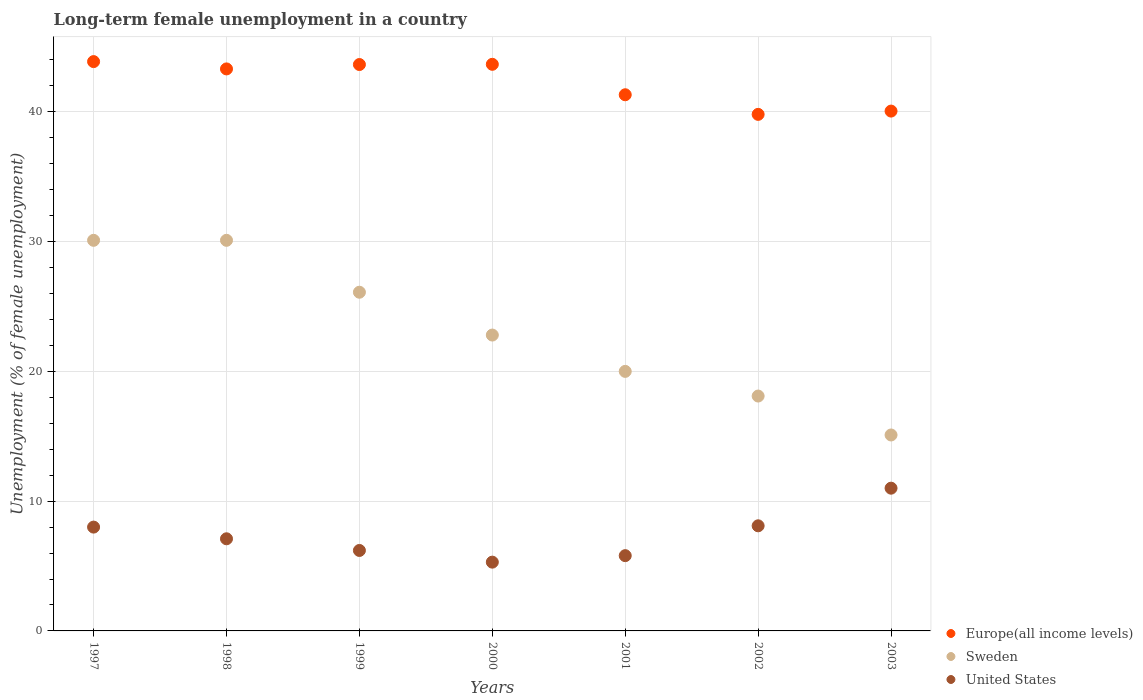What is the percentage of long-term unemployed female population in Europe(all income levels) in 2001?
Give a very brief answer. 41.32. Across all years, what is the minimum percentage of long-term unemployed female population in United States?
Make the answer very short. 5.3. In which year was the percentage of long-term unemployed female population in United States minimum?
Ensure brevity in your answer.  2000. What is the total percentage of long-term unemployed female population in Sweden in the graph?
Give a very brief answer. 162.3. What is the difference between the percentage of long-term unemployed female population in Sweden in 2000 and that in 2002?
Give a very brief answer. 4.7. What is the difference between the percentage of long-term unemployed female population in Sweden in 1997 and the percentage of long-term unemployed female population in United States in 2000?
Your response must be concise. 24.8. What is the average percentage of long-term unemployed female population in Sweden per year?
Give a very brief answer. 23.19. In the year 2000, what is the difference between the percentage of long-term unemployed female population in Europe(all income levels) and percentage of long-term unemployed female population in United States?
Give a very brief answer. 38.36. What is the ratio of the percentage of long-term unemployed female population in Sweden in 1998 to that in 2003?
Provide a short and direct response. 1.99. Is the percentage of long-term unemployed female population in Europe(all income levels) in 1997 less than that in 1998?
Provide a succinct answer. No. Is the difference between the percentage of long-term unemployed female population in Europe(all income levels) in 1999 and 2000 greater than the difference between the percentage of long-term unemployed female population in United States in 1999 and 2000?
Provide a short and direct response. No. What is the difference between the highest and the second highest percentage of long-term unemployed female population in United States?
Offer a terse response. 2.9. What is the difference between the highest and the lowest percentage of long-term unemployed female population in United States?
Ensure brevity in your answer.  5.7. In how many years, is the percentage of long-term unemployed female population in Sweden greater than the average percentage of long-term unemployed female population in Sweden taken over all years?
Your response must be concise. 3. Is the sum of the percentage of long-term unemployed female population in United States in 1999 and 2000 greater than the maximum percentage of long-term unemployed female population in Sweden across all years?
Your answer should be very brief. No. Does the percentage of long-term unemployed female population in Europe(all income levels) monotonically increase over the years?
Give a very brief answer. No. Is the percentage of long-term unemployed female population in Sweden strictly greater than the percentage of long-term unemployed female population in Europe(all income levels) over the years?
Provide a short and direct response. No. Is the percentage of long-term unemployed female population in Sweden strictly less than the percentage of long-term unemployed female population in Europe(all income levels) over the years?
Keep it short and to the point. Yes. How many dotlines are there?
Give a very brief answer. 3. How many years are there in the graph?
Keep it short and to the point. 7. What is the difference between two consecutive major ticks on the Y-axis?
Your answer should be very brief. 10. Are the values on the major ticks of Y-axis written in scientific E-notation?
Your answer should be very brief. No. Where does the legend appear in the graph?
Offer a terse response. Bottom right. How are the legend labels stacked?
Offer a very short reply. Vertical. What is the title of the graph?
Ensure brevity in your answer.  Long-term female unemployment in a country. Does "Lao PDR" appear as one of the legend labels in the graph?
Provide a succinct answer. No. What is the label or title of the X-axis?
Your answer should be very brief. Years. What is the label or title of the Y-axis?
Provide a succinct answer. Unemployment (% of female unemployment). What is the Unemployment (% of female unemployment) in Europe(all income levels) in 1997?
Your response must be concise. 43.87. What is the Unemployment (% of female unemployment) of Sweden in 1997?
Give a very brief answer. 30.1. What is the Unemployment (% of female unemployment) in United States in 1997?
Keep it short and to the point. 8. What is the Unemployment (% of female unemployment) in Europe(all income levels) in 1998?
Offer a terse response. 43.31. What is the Unemployment (% of female unemployment) of Sweden in 1998?
Ensure brevity in your answer.  30.1. What is the Unemployment (% of female unemployment) in United States in 1998?
Make the answer very short. 7.1. What is the Unemployment (% of female unemployment) of Europe(all income levels) in 1999?
Offer a terse response. 43.65. What is the Unemployment (% of female unemployment) of Sweden in 1999?
Provide a succinct answer. 26.1. What is the Unemployment (% of female unemployment) in United States in 1999?
Provide a short and direct response. 6.2. What is the Unemployment (% of female unemployment) of Europe(all income levels) in 2000?
Provide a short and direct response. 43.66. What is the Unemployment (% of female unemployment) in Sweden in 2000?
Your answer should be compact. 22.8. What is the Unemployment (% of female unemployment) in United States in 2000?
Ensure brevity in your answer.  5.3. What is the Unemployment (% of female unemployment) in Europe(all income levels) in 2001?
Ensure brevity in your answer.  41.32. What is the Unemployment (% of female unemployment) in United States in 2001?
Your response must be concise. 5.8. What is the Unemployment (% of female unemployment) in Europe(all income levels) in 2002?
Offer a terse response. 39.81. What is the Unemployment (% of female unemployment) in Sweden in 2002?
Provide a succinct answer. 18.1. What is the Unemployment (% of female unemployment) in United States in 2002?
Your response must be concise. 8.1. What is the Unemployment (% of female unemployment) in Europe(all income levels) in 2003?
Make the answer very short. 40.06. What is the Unemployment (% of female unemployment) in Sweden in 2003?
Your answer should be very brief. 15.1. What is the Unemployment (% of female unemployment) of United States in 2003?
Provide a short and direct response. 11. Across all years, what is the maximum Unemployment (% of female unemployment) in Europe(all income levels)?
Your response must be concise. 43.87. Across all years, what is the maximum Unemployment (% of female unemployment) of Sweden?
Make the answer very short. 30.1. Across all years, what is the minimum Unemployment (% of female unemployment) of Europe(all income levels)?
Keep it short and to the point. 39.81. Across all years, what is the minimum Unemployment (% of female unemployment) in Sweden?
Your response must be concise. 15.1. Across all years, what is the minimum Unemployment (% of female unemployment) of United States?
Offer a terse response. 5.3. What is the total Unemployment (% of female unemployment) in Europe(all income levels) in the graph?
Ensure brevity in your answer.  295.67. What is the total Unemployment (% of female unemployment) of Sweden in the graph?
Your response must be concise. 162.3. What is the total Unemployment (% of female unemployment) in United States in the graph?
Your answer should be compact. 51.5. What is the difference between the Unemployment (% of female unemployment) in Europe(all income levels) in 1997 and that in 1998?
Offer a terse response. 0.56. What is the difference between the Unemployment (% of female unemployment) in Sweden in 1997 and that in 1998?
Your answer should be compact. 0. What is the difference between the Unemployment (% of female unemployment) of United States in 1997 and that in 1998?
Offer a terse response. 0.9. What is the difference between the Unemployment (% of female unemployment) of Europe(all income levels) in 1997 and that in 1999?
Make the answer very short. 0.23. What is the difference between the Unemployment (% of female unemployment) of Sweden in 1997 and that in 1999?
Offer a terse response. 4. What is the difference between the Unemployment (% of female unemployment) in United States in 1997 and that in 1999?
Offer a terse response. 1.8. What is the difference between the Unemployment (% of female unemployment) in Europe(all income levels) in 1997 and that in 2000?
Provide a succinct answer. 0.21. What is the difference between the Unemployment (% of female unemployment) in Sweden in 1997 and that in 2000?
Offer a very short reply. 7.3. What is the difference between the Unemployment (% of female unemployment) of United States in 1997 and that in 2000?
Make the answer very short. 2.7. What is the difference between the Unemployment (% of female unemployment) in Europe(all income levels) in 1997 and that in 2001?
Your answer should be compact. 2.55. What is the difference between the Unemployment (% of female unemployment) in Sweden in 1997 and that in 2001?
Your response must be concise. 10.1. What is the difference between the Unemployment (% of female unemployment) of United States in 1997 and that in 2001?
Keep it short and to the point. 2.2. What is the difference between the Unemployment (% of female unemployment) of Europe(all income levels) in 1997 and that in 2002?
Your answer should be very brief. 4.07. What is the difference between the Unemployment (% of female unemployment) in Sweden in 1997 and that in 2002?
Your answer should be compact. 12. What is the difference between the Unemployment (% of female unemployment) of United States in 1997 and that in 2002?
Your response must be concise. -0.1. What is the difference between the Unemployment (% of female unemployment) of Europe(all income levels) in 1997 and that in 2003?
Offer a very short reply. 3.81. What is the difference between the Unemployment (% of female unemployment) in Sweden in 1997 and that in 2003?
Your answer should be compact. 15. What is the difference between the Unemployment (% of female unemployment) in Europe(all income levels) in 1998 and that in 1999?
Offer a very short reply. -0.34. What is the difference between the Unemployment (% of female unemployment) in Europe(all income levels) in 1998 and that in 2000?
Give a very brief answer. -0.35. What is the difference between the Unemployment (% of female unemployment) of Europe(all income levels) in 1998 and that in 2001?
Make the answer very short. 1.99. What is the difference between the Unemployment (% of female unemployment) of Sweden in 1998 and that in 2001?
Offer a terse response. 10.1. What is the difference between the Unemployment (% of female unemployment) in Europe(all income levels) in 1998 and that in 2002?
Your answer should be very brief. 3.5. What is the difference between the Unemployment (% of female unemployment) in Sweden in 1998 and that in 2002?
Make the answer very short. 12. What is the difference between the Unemployment (% of female unemployment) in United States in 1998 and that in 2002?
Your answer should be very brief. -1. What is the difference between the Unemployment (% of female unemployment) of Europe(all income levels) in 1998 and that in 2003?
Give a very brief answer. 3.25. What is the difference between the Unemployment (% of female unemployment) in Sweden in 1998 and that in 2003?
Offer a terse response. 15. What is the difference between the Unemployment (% of female unemployment) in United States in 1998 and that in 2003?
Your answer should be compact. -3.9. What is the difference between the Unemployment (% of female unemployment) of Europe(all income levels) in 1999 and that in 2000?
Your answer should be very brief. -0.02. What is the difference between the Unemployment (% of female unemployment) of Sweden in 1999 and that in 2000?
Provide a short and direct response. 3.3. What is the difference between the Unemployment (% of female unemployment) of Europe(all income levels) in 1999 and that in 2001?
Your answer should be compact. 2.33. What is the difference between the Unemployment (% of female unemployment) in Sweden in 1999 and that in 2001?
Provide a short and direct response. 6.1. What is the difference between the Unemployment (% of female unemployment) of United States in 1999 and that in 2001?
Make the answer very short. 0.4. What is the difference between the Unemployment (% of female unemployment) of Europe(all income levels) in 1999 and that in 2002?
Your answer should be compact. 3.84. What is the difference between the Unemployment (% of female unemployment) of United States in 1999 and that in 2002?
Your answer should be very brief. -1.9. What is the difference between the Unemployment (% of female unemployment) of Europe(all income levels) in 1999 and that in 2003?
Your response must be concise. 3.59. What is the difference between the Unemployment (% of female unemployment) in Europe(all income levels) in 2000 and that in 2001?
Make the answer very short. 2.35. What is the difference between the Unemployment (% of female unemployment) in Sweden in 2000 and that in 2001?
Your answer should be compact. 2.8. What is the difference between the Unemployment (% of female unemployment) of Europe(all income levels) in 2000 and that in 2002?
Your answer should be compact. 3.86. What is the difference between the Unemployment (% of female unemployment) of Europe(all income levels) in 2000 and that in 2003?
Offer a terse response. 3.6. What is the difference between the Unemployment (% of female unemployment) in United States in 2000 and that in 2003?
Keep it short and to the point. -5.7. What is the difference between the Unemployment (% of female unemployment) in Europe(all income levels) in 2001 and that in 2002?
Keep it short and to the point. 1.51. What is the difference between the Unemployment (% of female unemployment) of Sweden in 2001 and that in 2002?
Keep it short and to the point. 1.9. What is the difference between the Unemployment (% of female unemployment) in Europe(all income levels) in 2001 and that in 2003?
Provide a short and direct response. 1.26. What is the difference between the Unemployment (% of female unemployment) of Sweden in 2001 and that in 2003?
Provide a short and direct response. 4.9. What is the difference between the Unemployment (% of female unemployment) in Europe(all income levels) in 2002 and that in 2003?
Keep it short and to the point. -0.25. What is the difference between the Unemployment (% of female unemployment) in Sweden in 2002 and that in 2003?
Offer a very short reply. 3. What is the difference between the Unemployment (% of female unemployment) of United States in 2002 and that in 2003?
Offer a very short reply. -2.9. What is the difference between the Unemployment (% of female unemployment) of Europe(all income levels) in 1997 and the Unemployment (% of female unemployment) of Sweden in 1998?
Offer a very short reply. 13.77. What is the difference between the Unemployment (% of female unemployment) of Europe(all income levels) in 1997 and the Unemployment (% of female unemployment) of United States in 1998?
Offer a terse response. 36.77. What is the difference between the Unemployment (% of female unemployment) of Sweden in 1997 and the Unemployment (% of female unemployment) of United States in 1998?
Offer a very short reply. 23. What is the difference between the Unemployment (% of female unemployment) in Europe(all income levels) in 1997 and the Unemployment (% of female unemployment) in Sweden in 1999?
Make the answer very short. 17.77. What is the difference between the Unemployment (% of female unemployment) of Europe(all income levels) in 1997 and the Unemployment (% of female unemployment) of United States in 1999?
Provide a short and direct response. 37.67. What is the difference between the Unemployment (% of female unemployment) of Sweden in 1997 and the Unemployment (% of female unemployment) of United States in 1999?
Give a very brief answer. 23.9. What is the difference between the Unemployment (% of female unemployment) in Europe(all income levels) in 1997 and the Unemployment (% of female unemployment) in Sweden in 2000?
Provide a short and direct response. 21.07. What is the difference between the Unemployment (% of female unemployment) in Europe(all income levels) in 1997 and the Unemployment (% of female unemployment) in United States in 2000?
Provide a short and direct response. 38.57. What is the difference between the Unemployment (% of female unemployment) of Sweden in 1997 and the Unemployment (% of female unemployment) of United States in 2000?
Your answer should be very brief. 24.8. What is the difference between the Unemployment (% of female unemployment) in Europe(all income levels) in 1997 and the Unemployment (% of female unemployment) in Sweden in 2001?
Your answer should be compact. 23.87. What is the difference between the Unemployment (% of female unemployment) of Europe(all income levels) in 1997 and the Unemployment (% of female unemployment) of United States in 2001?
Provide a short and direct response. 38.07. What is the difference between the Unemployment (% of female unemployment) of Sweden in 1997 and the Unemployment (% of female unemployment) of United States in 2001?
Ensure brevity in your answer.  24.3. What is the difference between the Unemployment (% of female unemployment) of Europe(all income levels) in 1997 and the Unemployment (% of female unemployment) of Sweden in 2002?
Provide a succinct answer. 25.77. What is the difference between the Unemployment (% of female unemployment) in Europe(all income levels) in 1997 and the Unemployment (% of female unemployment) in United States in 2002?
Your answer should be compact. 35.77. What is the difference between the Unemployment (% of female unemployment) in Europe(all income levels) in 1997 and the Unemployment (% of female unemployment) in Sweden in 2003?
Offer a terse response. 28.77. What is the difference between the Unemployment (% of female unemployment) in Europe(all income levels) in 1997 and the Unemployment (% of female unemployment) in United States in 2003?
Give a very brief answer. 32.87. What is the difference between the Unemployment (% of female unemployment) of Sweden in 1997 and the Unemployment (% of female unemployment) of United States in 2003?
Your response must be concise. 19.1. What is the difference between the Unemployment (% of female unemployment) in Europe(all income levels) in 1998 and the Unemployment (% of female unemployment) in Sweden in 1999?
Offer a terse response. 17.21. What is the difference between the Unemployment (% of female unemployment) of Europe(all income levels) in 1998 and the Unemployment (% of female unemployment) of United States in 1999?
Your response must be concise. 37.11. What is the difference between the Unemployment (% of female unemployment) of Sweden in 1998 and the Unemployment (% of female unemployment) of United States in 1999?
Give a very brief answer. 23.9. What is the difference between the Unemployment (% of female unemployment) in Europe(all income levels) in 1998 and the Unemployment (% of female unemployment) in Sweden in 2000?
Make the answer very short. 20.51. What is the difference between the Unemployment (% of female unemployment) of Europe(all income levels) in 1998 and the Unemployment (% of female unemployment) of United States in 2000?
Ensure brevity in your answer.  38.01. What is the difference between the Unemployment (% of female unemployment) of Sweden in 1998 and the Unemployment (% of female unemployment) of United States in 2000?
Ensure brevity in your answer.  24.8. What is the difference between the Unemployment (% of female unemployment) in Europe(all income levels) in 1998 and the Unemployment (% of female unemployment) in Sweden in 2001?
Offer a terse response. 23.31. What is the difference between the Unemployment (% of female unemployment) of Europe(all income levels) in 1998 and the Unemployment (% of female unemployment) of United States in 2001?
Your answer should be very brief. 37.51. What is the difference between the Unemployment (% of female unemployment) of Sweden in 1998 and the Unemployment (% of female unemployment) of United States in 2001?
Your answer should be compact. 24.3. What is the difference between the Unemployment (% of female unemployment) in Europe(all income levels) in 1998 and the Unemployment (% of female unemployment) in Sweden in 2002?
Offer a very short reply. 25.21. What is the difference between the Unemployment (% of female unemployment) in Europe(all income levels) in 1998 and the Unemployment (% of female unemployment) in United States in 2002?
Keep it short and to the point. 35.21. What is the difference between the Unemployment (% of female unemployment) of Europe(all income levels) in 1998 and the Unemployment (% of female unemployment) of Sweden in 2003?
Provide a succinct answer. 28.21. What is the difference between the Unemployment (% of female unemployment) in Europe(all income levels) in 1998 and the Unemployment (% of female unemployment) in United States in 2003?
Your answer should be compact. 32.31. What is the difference between the Unemployment (% of female unemployment) of Europe(all income levels) in 1999 and the Unemployment (% of female unemployment) of Sweden in 2000?
Make the answer very short. 20.85. What is the difference between the Unemployment (% of female unemployment) in Europe(all income levels) in 1999 and the Unemployment (% of female unemployment) in United States in 2000?
Ensure brevity in your answer.  38.35. What is the difference between the Unemployment (% of female unemployment) in Sweden in 1999 and the Unemployment (% of female unemployment) in United States in 2000?
Offer a terse response. 20.8. What is the difference between the Unemployment (% of female unemployment) in Europe(all income levels) in 1999 and the Unemployment (% of female unemployment) in Sweden in 2001?
Provide a short and direct response. 23.65. What is the difference between the Unemployment (% of female unemployment) of Europe(all income levels) in 1999 and the Unemployment (% of female unemployment) of United States in 2001?
Give a very brief answer. 37.85. What is the difference between the Unemployment (% of female unemployment) in Sweden in 1999 and the Unemployment (% of female unemployment) in United States in 2001?
Your answer should be very brief. 20.3. What is the difference between the Unemployment (% of female unemployment) of Europe(all income levels) in 1999 and the Unemployment (% of female unemployment) of Sweden in 2002?
Give a very brief answer. 25.55. What is the difference between the Unemployment (% of female unemployment) of Europe(all income levels) in 1999 and the Unemployment (% of female unemployment) of United States in 2002?
Make the answer very short. 35.55. What is the difference between the Unemployment (% of female unemployment) in Sweden in 1999 and the Unemployment (% of female unemployment) in United States in 2002?
Give a very brief answer. 18. What is the difference between the Unemployment (% of female unemployment) in Europe(all income levels) in 1999 and the Unemployment (% of female unemployment) in Sweden in 2003?
Your answer should be very brief. 28.55. What is the difference between the Unemployment (% of female unemployment) of Europe(all income levels) in 1999 and the Unemployment (% of female unemployment) of United States in 2003?
Offer a terse response. 32.65. What is the difference between the Unemployment (% of female unemployment) in Europe(all income levels) in 2000 and the Unemployment (% of female unemployment) in Sweden in 2001?
Keep it short and to the point. 23.66. What is the difference between the Unemployment (% of female unemployment) in Europe(all income levels) in 2000 and the Unemployment (% of female unemployment) in United States in 2001?
Keep it short and to the point. 37.86. What is the difference between the Unemployment (% of female unemployment) of Sweden in 2000 and the Unemployment (% of female unemployment) of United States in 2001?
Make the answer very short. 17. What is the difference between the Unemployment (% of female unemployment) of Europe(all income levels) in 2000 and the Unemployment (% of female unemployment) of Sweden in 2002?
Your answer should be very brief. 25.56. What is the difference between the Unemployment (% of female unemployment) in Europe(all income levels) in 2000 and the Unemployment (% of female unemployment) in United States in 2002?
Give a very brief answer. 35.56. What is the difference between the Unemployment (% of female unemployment) in Europe(all income levels) in 2000 and the Unemployment (% of female unemployment) in Sweden in 2003?
Ensure brevity in your answer.  28.56. What is the difference between the Unemployment (% of female unemployment) in Europe(all income levels) in 2000 and the Unemployment (% of female unemployment) in United States in 2003?
Your answer should be very brief. 32.66. What is the difference between the Unemployment (% of female unemployment) of Europe(all income levels) in 2001 and the Unemployment (% of female unemployment) of Sweden in 2002?
Give a very brief answer. 23.22. What is the difference between the Unemployment (% of female unemployment) in Europe(all income levels) in 2001 and the Unemployment (% of female unemployment) in United States in 2002?
Provide a short and direct response. 33.22. What is the difference between the Unemployment (% of female unemployment) of Sweden in 2001 and the Unemployment (% of female unemployment) of United States in 2002?
Provide a short and direct response. 11.9. What is the difference between the Unemployment (% of female unemployment) of Europe(all income levels) in 2001 and the Unemployment (% of female unemployment) of Sweden in 2003?
Provide a short and direct response. 26.22. What is the difference between the Unemployment (% of female unemployment) of Europe(all income levels) in 2001 and the Unemployment (% of female unemployment) of United States in 2003?
Provide a short and direct response. 30.32. What is the difference between the Unemployment (% of female unemployment) of Europe(all income levels) in 2002 and the Unemployment (% of female unemployment) of Sweden in 2003?
Keep it short and to the point. 24.71. What is the difference between the Unemployment (% of female unemployment) of Europe(all income levels) in 2002 and the Unemployment (% of female unemployment) of United States in 2003?
Provide a short and direct response. 28.81. What is the difference between the Unemployment (% of female unemployment) in Sweden in 2002 and the Unemployment (% of female unemployment) in United States in 2003?
Provide a short and direct response. 7.1. What is the average Unemployment (% of female unemployment) of Europe(all income levels) per year?
Make the answer very short. 42.24. What is the average Unemployment (% of female unemployment) in Sweden per year?
Your response must be concise. 23.19. What is the average Unemployment (% of female unemployment) of United States per year?
Your response must be concise. 7.36. In the year 1997, what is the difference between the Unemployment (% of female unemployment) of Europe(all income levels) and Unemployment (% of female unemployment) of Sweden?
Your response must be concise. 13.77. In the year 1997, what is the difference between the Unemployment (% of female unemployment) in Europe(all income levels) and Unemployment (% of female unemployment) in United States?
Offer a terse response. 35.87. In the year 1997, what is the difference between the Unemployment (% of female unemployment) in Sweden and Unemployment (% of female unemployment) in United States?
Your response must be concise. 22.1. In the year 1998, what is the difference between the Unemployment (% of female unemployment) of Europe(all income levels) and Unemployment (% of female unemployment) of Sweden?
Make the answer very short. 13.21. In the year 1998, what is the difference between the Unemployment (% of female unemployment) of Europe(all income levels) and Unemployment (% of female unemployment) of United States?
Offer a terse response. 36.21. In the year 1998, what is the difference between the Unemployment (% of female unemployment) in Sweden and Unemployment (% of female unemployment) in United States?
Your answer should be compact. 23. In the year 1999, what is the difference between the Unemployment (% of female unemployment) of Europe(all income levels) and Unemployment (% of female unemployment) of Sweden?
Make the answer very short. 17.55. In the year 1999, what is the difference between the Unemployment (% of female unemployment) in Europe(all income levels) and Unemployment (% of female unemployment) in United States?
Your answer should be very brief. 37.45. In the year 1999, what is the difference between the Unemployment (% of female unemployment) of Sweden and Unemployment (% of female unemployment) of United States?
Your answer should be very brief. 19.9. In the year 2000, what is the difference between the Unemployment (% of female unemployment) in Europe(all income levels) and Unemployment (% of female unemployment) in Sweden?
Keep it short and to the point. 20.86. In the year 2000, what is the difference between the Unemployment (% of female unemployment) in Europe(all income levels) and Unemployment (% of female unemployment) in United States?
Ensure brevity in your answer.  38.36. In the year 2001, what is the difference between the Unemployment (% of female unemployment) in Europe(all income levels) and Unemployment (% of female unemployment) in Sweden?
Provide a succinct answer. 21.32. In the year 2001, what is the difference between the Unemployment (% of female unemployment) in Europe(all income levels) and Unemployment (% of female unemployment) in United States?
Your response must be concise. 35.52. In the year 2001, what is the difference between the Unemployment (% of female unemployment) in Sweden and Unemployment (% of female unemployment) in United States?
Offer a very short reply. 14.2. In the year 2002, what is the difference between the Unemployment (% of female unemployment) of Europe(all income levels) and Unemployment (% of female unemployment) of Sweden?
Provide a succinct answer. 21.71. In the year 2002, what is the difference between the Unemployment (% of female unemployment) in Europe(all income levels) and Unemployment (% of female unemployment) in United States?
Your answer should be compact. 31.71. In the year 2003, what is the difference between the Unemployment (% of female unemployment) in Europe(all income levels) and Unemployment (% of female unemployment) in Sweden?
Provide a succinct answer. 24.96. In the year 2003, what is the difference between the Unemployment (% of female unemployment) in Europe(all income levels) and Unemployment (% of female unemployment) in United States?
Provide a short and direct response. 29.06. What is the ratio of the Unemployment (% of female unemployment) of United States in 1997 to that in 1998?
Provide a succinct answer. 1.13. What is the ratio of the Unemployment (% of female unemployment) in Europe(all income levels) in 1997 to that in 1999?
Your response must be concise. 1.01. What is the ratio of the Unemployment (% of female unemployment) of Sweden in 1997 to that in 1999?
Make the answer very short. 1.15. What is the ratio of the Unemployment (% of female unemployment) of United States in 1997 to that in 1999?
Keep it short and to the point. 1.29. What is the ratio of the Unemployment (% of female unemployment) of Sweden in 1997 to that in 2000?
Make the answer very short. 1.32. What is the ratio of the Unemployment (% of female unemployment) in United States in 1997 to that in 2000?
Offer a terse response. 1.51. What is the ratio of the Unemployment (% of female unemployment) in Europe(all income levels) in 1997 to that in 2001?
Ensure brevity in your answer.  1.06. What is the ratio of the Unemployment (% of female unemployment) in Sweden in 1997 to that in 2001?
Keep it short and to the point. 1.5. What is the ratio of the Unemployment (% of female unemployment) in United States in 1997 to that in 2001?
Give a very brief answer. 1.38. What is the ratio of the Unemployment (% of female unemployment) in Europe(all income levels) in 1997 to that in 2002?
Offer a very short reply. 1.1. What is the ratio of the Unemployment (% of female unemployment) in Sweden in 1997 to that in 2002?
Provide a short and direct response. 1.66. What is the ratio of the Unemployment (% of female unemployment) in United States in 1997 to that in 2002?
Offer a terse response. 0.99. What is the ratio of the Unemployment (% of female unemployment) of Europe(all income levels) in 1997 to that in 2003?
Give a very brief answer. 1.1. What is the ratio of the Unemployment (% of female unemployment) of Sweden in 1997 to that in 2003?
Provide a short and direct response. 1.99. What is the ratio of the Unemployment (% of female unemployment) of United States in 1997 to that in 2003?
Your answer should be compact. 0.73. What is the ratio of the Unemployment (% of female unemployment) of Europe(all income levels) in 1998 to that in 1999?
Provide a succinct answer. 0.99. What is the ratio of the Unemployment (% of female unemployment) of Sweden in 1998 to that in 1999?
Your response must be concise. 1.15. What is the ratio of the Unemployment (% of female unemployment) in United States in 1998 to that in 1999?
Offer a terse response. 1.15. What is the ratio of the Unemployment (% of female unemployment) of Europe(all income levels) in 1998 to that in 2000?
Ensure brevity in your answer.  0.99. What is the ratio of the Unemployment (% of female unemployment) of Sweden in 1998 to that in 2000?
Your answer should be very brief. 1.32. What is the ratio of the Unemployment (% of female unemployment) of United States in 1998 to that in 2000?
Offer a terse response. 1.34. What is the ratio of the Unemployment (% of female unemployment) of Europe(all income levels) in 1998 to that in 2001?
Your answer should be very brief. 1.05. What is the ratio of the Unemployment (% of female unemployment) in Sweden in 1998 to that in 2001?
Provide a short and direct response. 1.5. What is the ratio of the Unemployment (% of female unemployment) of United States in 1998 to that in 2001?
Provide a succinct answer. 1.22. What is the ratio of the Unemployment (% of female unemployment) of Europe(all income levels) in 1998 to that in 2002?
Your answer should be compact. 1.09. What is the ratio of the Unemployment (% of female unemployment) of Sweden in 1998 to that in 2002?
Your answer should be very brief. 1.66. What is the ratio of the Unemployment (% of female unemployment) of United States in 1998 to that in 2002?
Your answer should be compact. 0.88. What is the ratio of the Unemployment (% of female unemployment) of Europe(all income levels) in 1998 to that in 2003?
Your answer should be compact. 1.08. What is the ratio of the Unemployment (% of female unemployment) in Sweden in 1998 to that in 2003?
Your answer should be very brief. 1.99. What is the ratio of the Unemployment (% of female unemployment) in United States in 1998 to that in 2003?
Give a very brief answer. 0.65. What is the ratio of the Unemployment (% of female unemployment) in Europe(all income levels) in 1999 to that in 2000?
Keep it short and to the point. 1. What is the ratio of the Unemployment (% of female unemployment) of Sweden in 1999 to that in 2000?
Your answer should be very brief. 1.14. What is the ratio of the Unemployment (% of female unemployment) of United States in 1999 to that in 2000?
Your answer should be compact. 1.17. What is the ratio of the Unemployment (% of female unemployment) in Europe(all income levels) in 1999 to that in 2001?
Your answer should be very brief. 1.06. What is the ratio of the Unemployment (% of female unemployment) of Sweden in 1999 to that in 2001?
Your answer should be compact. 1.3. What is the ratio of the Unemployment (% of female unemployment) of United States in 1999 to that in 2001?
Provide a short and direct response. 1.07. What is the ratio of the Unemployment (% of female unemployment) in Europe(all income levels) in 1999 to that in 2002?
Ensure brevity in your answer.  1.1. What is the ratio of the Unemployment (% of female unemployment) in Sweden in 1999 to that in 2002?
Offer a terse response. 1.44. What is the ratio of the Unemployment (% of female unemployment) of United States in 1999 to that in 2002?
Your response must be concise. 0.77. What is the ratio of the Unemployment (% of female unemployment) of Europe(all income levels) in 1999 to that in 2003?
Your answer should be compact. 1.09. What is the ratio of the Unemployment (% of female unemployment) of Sweden in 1999 to that in 2003?
Keep it short and to the point. 1.73. What is the ratio of the Unemployment (% of female unemployment) of United States in 1999 to that in 2003?
Give a very brief answer. 0.56. What is the ratio of the Unemployment (% of female unemployment) in Europe(all income levels) in 2000 to that in 2001?
Ensure brevity in your answer.  1.06. What is the ratio of the Unemployment (% of female unemployment) of Sweden in 2000 to that in 2001?
Give a very brief answer. 1.14. What is the ratio of the Unemployment (% of female unemployment) in United States in 2000 to that in 2001?
Offer a terse response. 0.91. What is the ratio of the Unemployment (% of female unemployment) of Europe(all income levels) in 2000 to that in 2002?
Offer a very short reply. 1.1. What is the ratio of the Unemployment (% of female unemployment) in Sweden in 2000 to that in 2002?
Offer a very short reply. 1.26. What is the ratio of the Unemployment (% of female unemployment) in United States in 2000 to that in 2002?
Keep it short and to the point. 0.65. What is the ratio of the Unemployment (% of female unemployment) in Europe(all income levels) in 2000 to that in 2003?
Your answer should be very brief. 1.09. What is the ratio of the Unemployment (% of female unemployment) of Sweden in 2000 to that in 2003?
Your answer should be very brief. 1.51. What is the ratio of the Unemployment (% of female unemployment) of United States in 2000 to that in 2003?
Offer a terse response. 0.48. What is the ratio of the Unemployment (% of female unemployment) in Europe(all income levels) in 2001 to that in 2002?
Provide a succinct answer. 1.04. What is the ratio of the Unemployment (% of female unemployment) in Sweden in 2001 to that in 2002?
Offer a terse response. 1.1. What is the ratio of the Unemployment (% of female unemployment) in United States in 2001 to that in 2002?
Your answer should be compact. 0.72. What is the ratio of the Unemployment (% of female unemployment) of Europe(all income levels) in 2001 to that in 2003?
Ensure brevity in your answer.  1.03. What is the ratio of the Unemployment (% of female unemployment) of Sweden in 2001 to that in 2003?
Provide a short and direct response. 1.32. What is the ratio of the Unemployment (% of female unemployment) of United States in 2001 to that in 2003?
Provide a succinct answer. 0.53. What is the ratio of the Unemployment (% of female unemployment) in Sweden in 2002 to that in 2003?
Offer a very short reply. 1.2. What is the ratio of the Unemployment (% of female unemployment) of United States in 2002 to that in 2003?
Offer a very short reply. 0.74. What is the difference between the highest and the second highest Unemployment (% of female unemployment) of Europe(all income levels)?
Offer a terse response. 0.21. What is the difference between the highest and the second highest Unemployment (% of female unemployment) in Sweden?
Make the answer very short. 0. What is the difference between the highest and the lowest Unemployment (% of female unemployment) in Europe(all income levels)?
Make the answer very short. 4.07. What is the difference between the highest and the lowest Unemployment (% of female unemployment) in Sweden?
Ensure brevity in your answer.  15. What is the difference between the highest and the lowest Unemployment (% of female unemployment) of United States?
Keep it short and to the point. 5.7. 